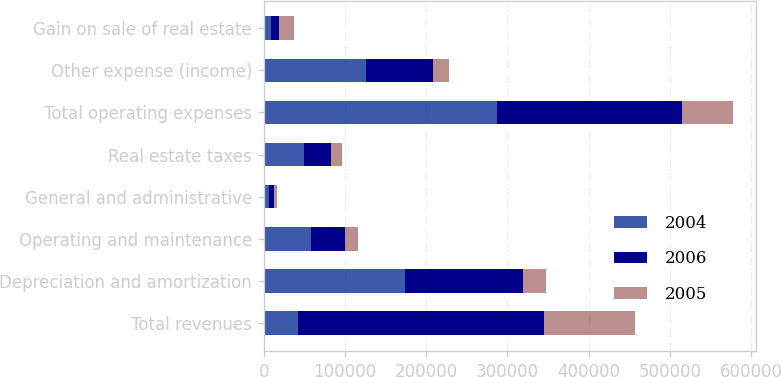<chart> <loc_0><loc_0><loc_500><loc_500><stacked_bar_chart><ecel><fcel>Total revenues<fcel>Depreciation and amortization<fcel>Operating and maintenance<fcel>General and administrative<fcel>Real estate taxes<fcel>Total operating expenses<fcel>Other expense (income)<fcel>Gain on sale of real estate<nl><fcel>2004<fcel>42206<fcel>173812<fcel>57844<fcel>6839<fcel>48983<fcel>287478<fcel>125378<fcel>9225<nl><fcel>2006<fcel>303448<fcel>145669<fcel>42206<fcel>6119<fcel>33726<fcel>227720<fcel>83352<fcel>9499<nl><fcel>2005<fcel>110939<fcel>28538<fcel>16513<fcel>3628<fcel>13448<fcel>62127<fcel>20000<fcel>18977<nl></chart> 